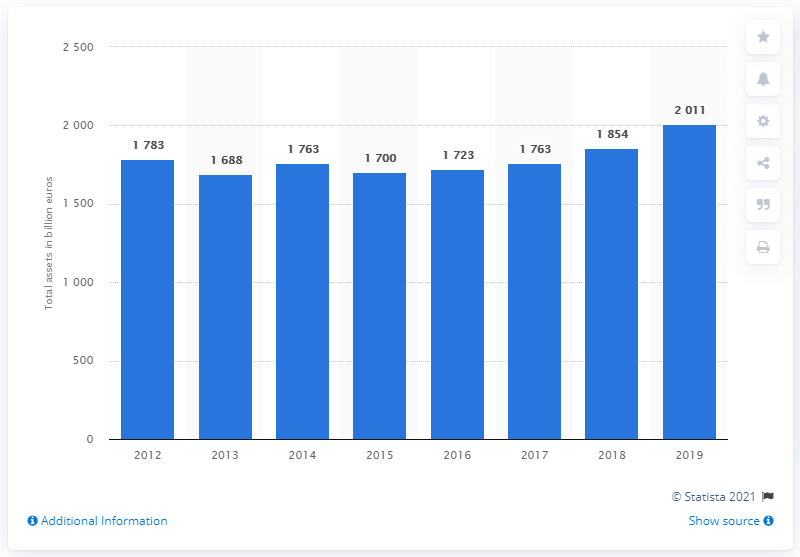Indicate a few pertinent items in this graphic. In 2019, Credit Agricole's total assets were X. 